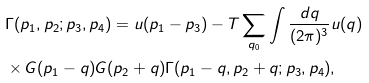Convert formula to latex. <formula><loc_0><loc_0><loc_500><loc_500>& \Gamma ( p _ { 1 } , p _ { 2 } ; p _ { 3 } , p _ { 4 } ) = u ( { p } _ { 1 } - { p } _ { 3 } ) - T \sum _ { q _ { 0 } } \int \frac { d { q } } { ( 2 \pi ) ^ { 3 } } u ( { q } ) \\ & \times G ( p _ { 1 } - q ) G ( p _ { 2 } + q ) \Gamma ( p _ { 1 } - q , p _ { 2 } + q ; p _ { 3 } , p _ { 4 } ) ,</formula> 